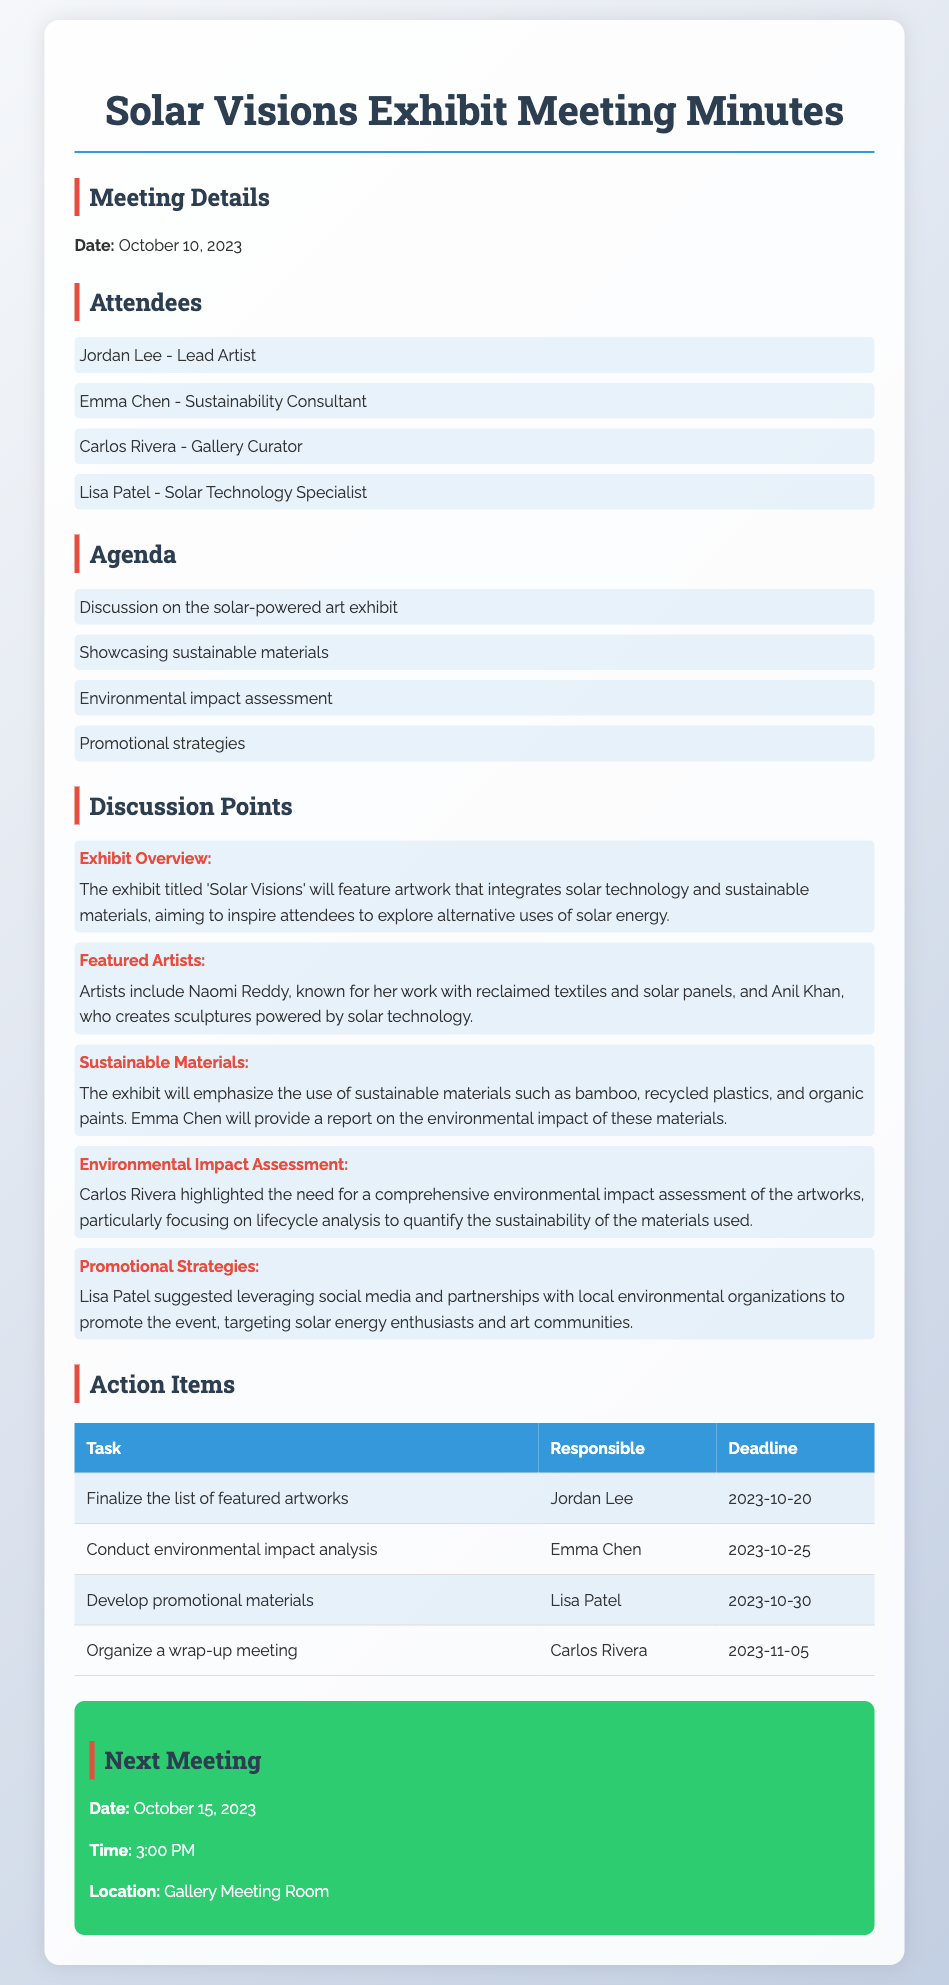What is the title of the exhibit? The title of the exhibit is mentioned in the overview section under Exhibit Overview, which is "Solar Visions."
Answer: Solar Visions Who is the Lead Artist? The Lead Artist is identified in the list of attendees as Jordan Lee.
Answer: Jordan Lee What sustainable materials will be emphasized in the exhibit? The materials to be emphasized are listed under Sustainable Materials, including bamboo, recycled plastics, and organic paints.
Answer: Bamboo, recycled plastics, and organic paints What date is the next meeting scheduled for? The next meeting date is provided in the section labeled Next Meeting, which states October 15, 2023.
Answer: October 15, 2023 Who is responsible for conducting the environmental impact analysis? The responsibility for this task is assigned to Emma Chen as mentioned in the Action Items section.
Answer: Emma Chen What is the deadline for finalizing the list of featured artworks? The deadline is specified in the Action Items table as October 20, 2023.
Answer: October 20, 2023 Which artist is known for working with reclaimed textiles and solar panels? The artist's name is mentioned in the Featured Artists section, which identifies Naomi Reddy.
Answer: Naomi Reddy What promotional strategy was suggested for the event? The promotional strategies suggested included leveraging social media and partnerships with local environmental organizations, as discussed by Lisa Patel.
Answer: Social media and partnerships with local environmental organizations 